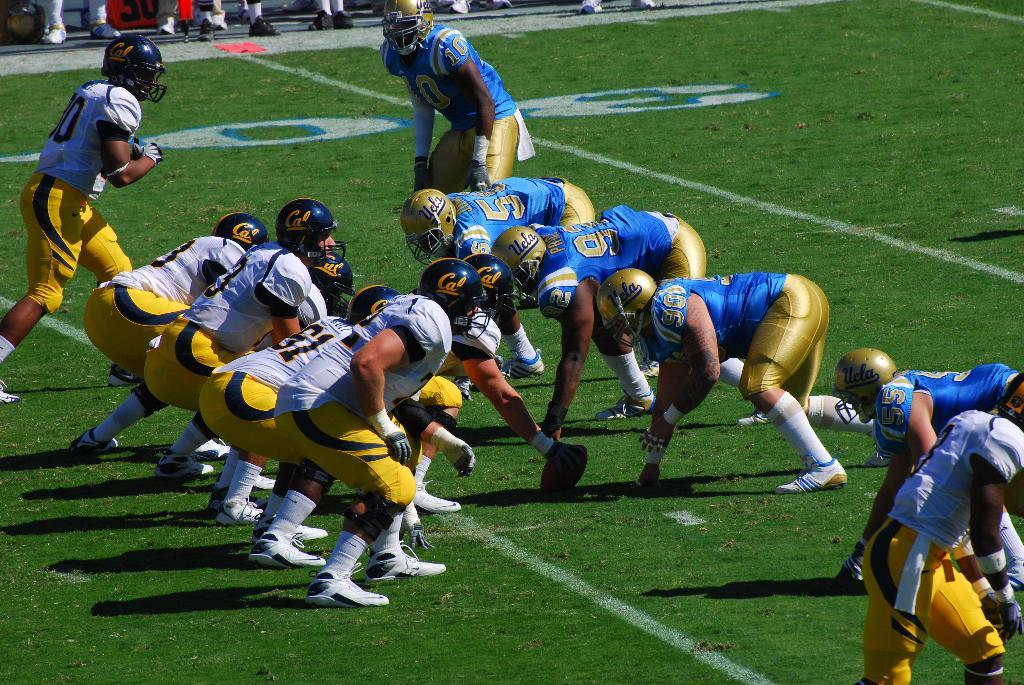What activity are the people in the center of the image engaged in? People are playing a sport in the center of the image. Can you describe the positioning of the people in the image? There are people standing on the ground at the back side of the image. What type of roof can be seen on the playing field in the image? There is no roof visible in the image, as it appears to be an outdoor sport being played. 